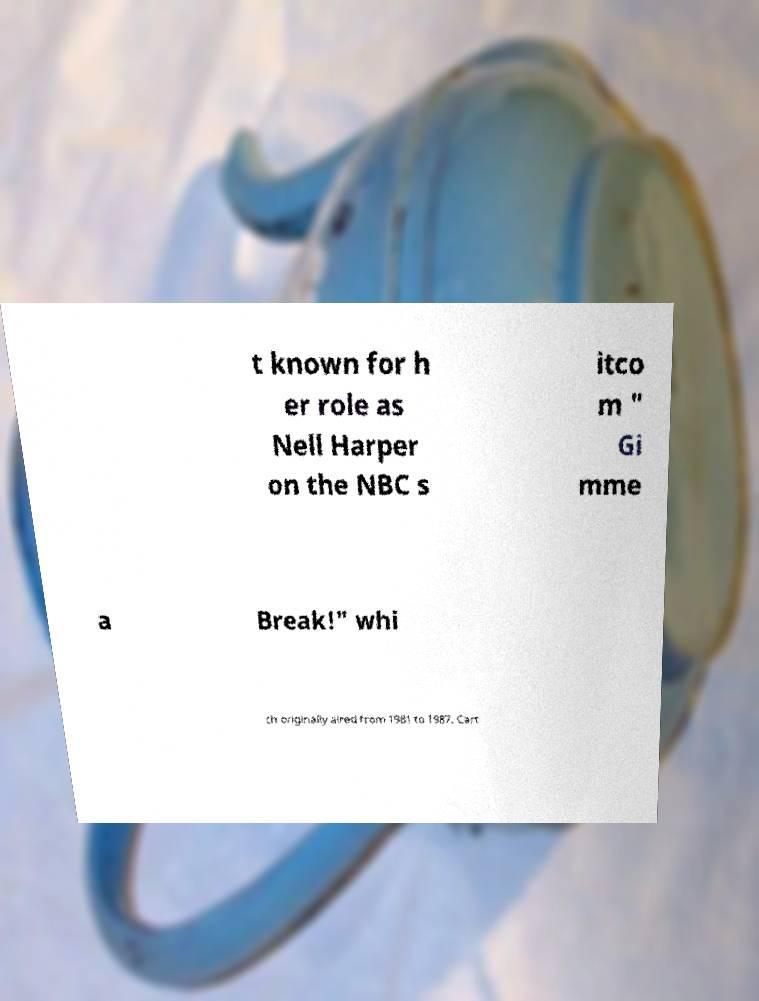Could you assist in decoding the text presented in this image and type it out clearly? t known for h er role as Nell Harper on the NBC s itco m " Gi mme a Break!" whi ch originally aired from 1981 to 1987. Cart 